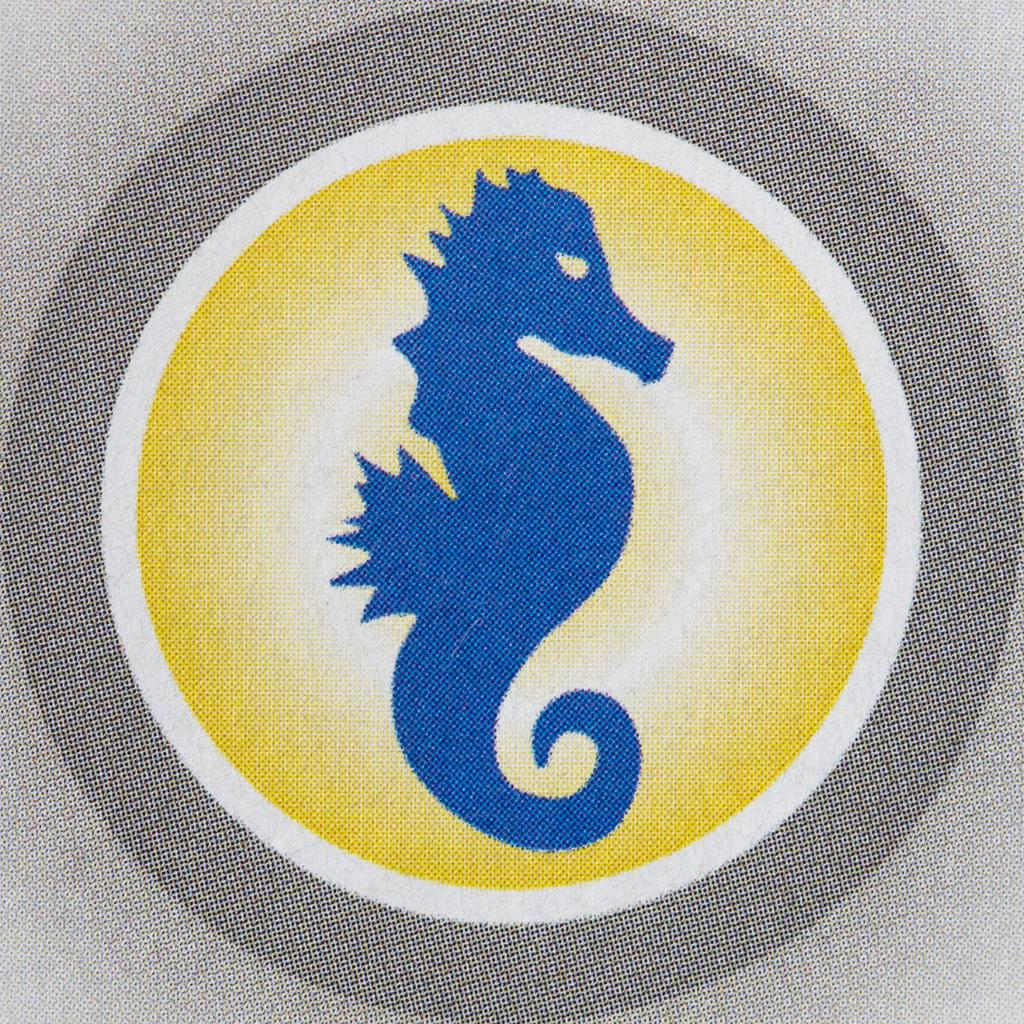What type of material is present in the image? There is cloth in the image. What design or pattern is featured on the cloth? The cloth has an animal print. What colors can be seen on the cloth? The cloth has blue, ash, white, and yellow colors. How many trees are visible in the image? There are no trees visible in the image; it only features cloth with an animal print. What day of the week is depicted in the image? The image does not depict a day of the week; it only features cloth with an animal print. 